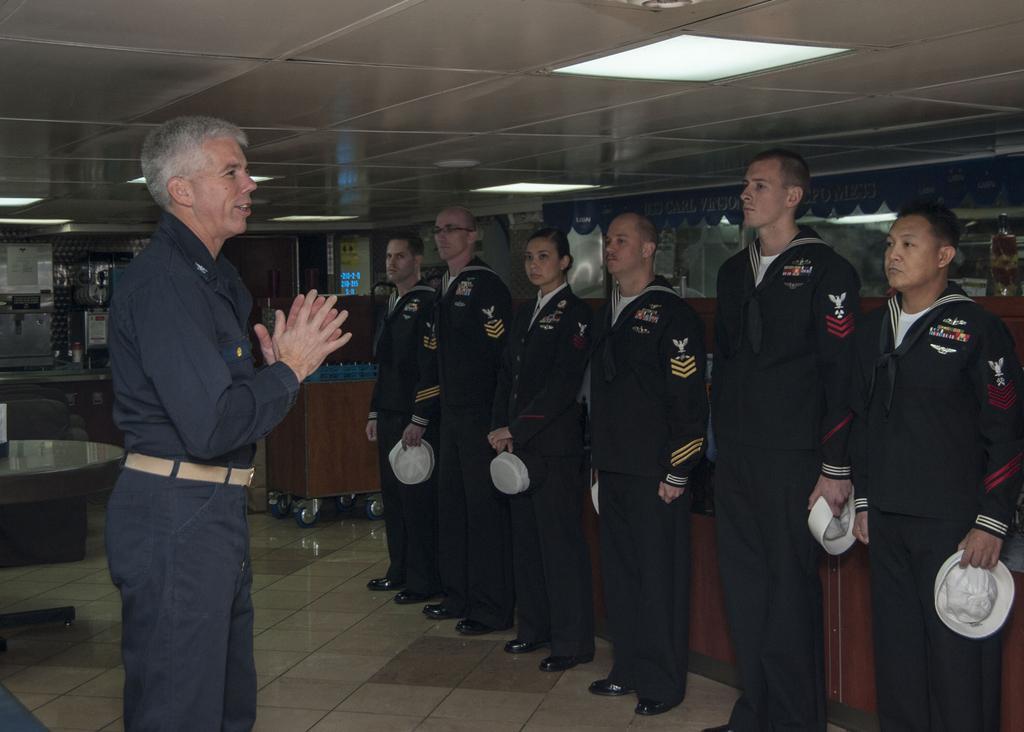How would you summarize this image in a sentence or two? In this picture there are people those who are standing in series on the right side of the image and there is a man who is standing on the left side of the image. 